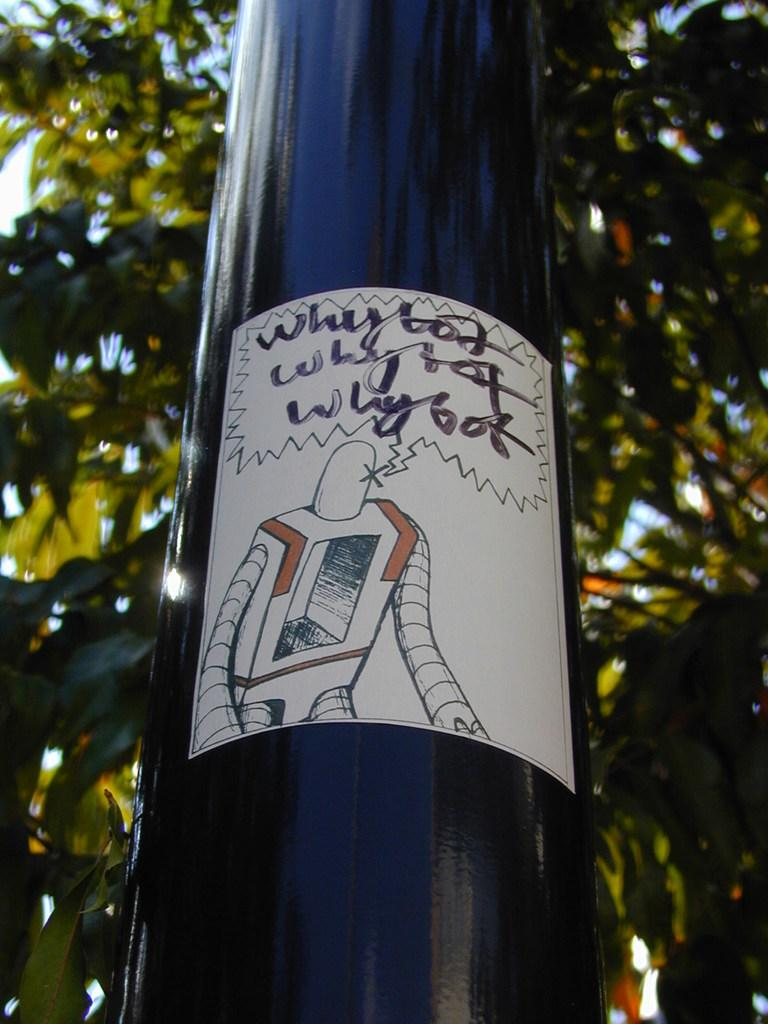Provide a one-sentence caption for the provided image. A robot questioning and thinking about the reason of its action. 